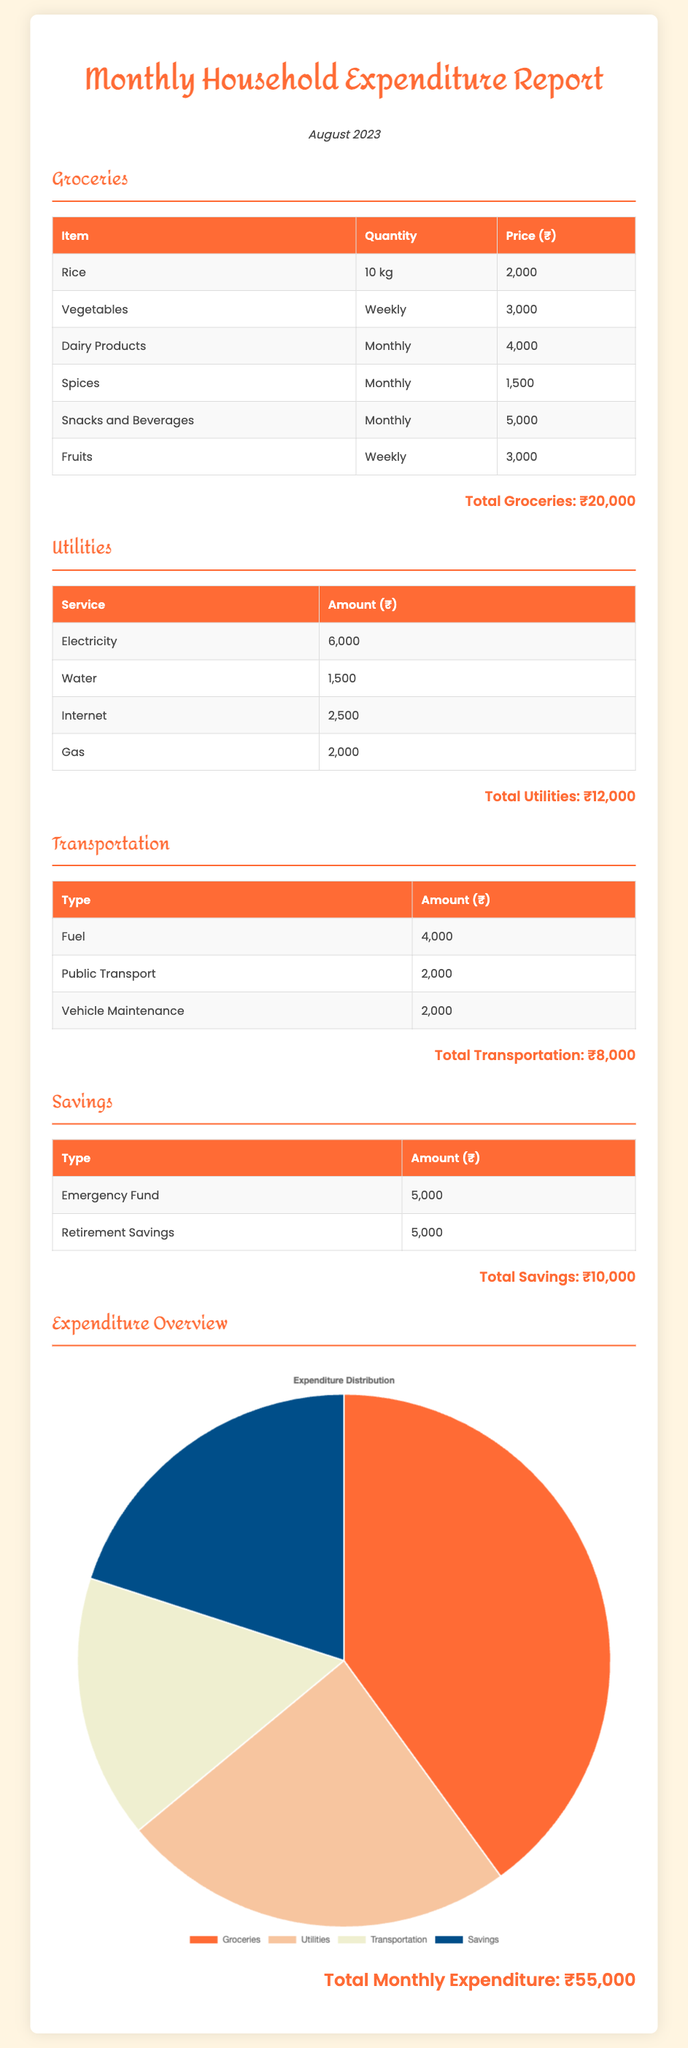What is the total amount spent on groceries? The total amount spent on groceries can be found in the Groceries section of the document, which states it is ₹20,000.
Answer: ₹20,000 What are the total utilities expenses? The document lists utility expenses and provides a total for them, which is ₹12,000.
Answer: ₹12,000 How much was spent on public transport? The specific public transport expense is listed under Transportation, amounting to ₹2,000.
Answer: ₹2,000 What percentage of total expenditure is spent on savings? Total savings amount is ₹10,000 and the total expenditure is ₹55,000, which leads to a calculation of (10,000/55,000) * 100 = 18.18%.
Answer: 18.18% Which category has the highest expenditure? By comparing the totals in all categories, Groceries has the highest expenditure at ₹20,000.
Answer: Groceries What is the total monthly expenditure? The document summarizes the total monthly expenditure which is presented at the end, showing ₹55,000.
Answer: ₹55,000 How much was spent on vehicle maintenance? Under the Transportation section, vehicle maintenance is specified with an amount of ₹2,000.
Answer: ₹2,000 How many different types of utilities are mentioned? The Utilities section includes four different services which are Electricity, Water, Internet, and Gas.
Answer: 4 What is the total amount allocated for the emergency fund? The amount allocated for the emergency fund is stated in the Savings section as ₹5,000.
Answer: ₹5,000 